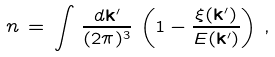Convert formula to latex. <formula><loc_0><loc_0><loc_500><loc_500>n \, = \, \int \, \frac { d { \mathbf k } ^ { \prime } } { ( 2 \pi ) ^ { 3 } } \, \left ( 1 - \frac { \xi ( { \mathbf k } ^ { \prime } ) } { E ( { \mathbf k } ^ { \prime } ) } \right ) \, ,</formula> 